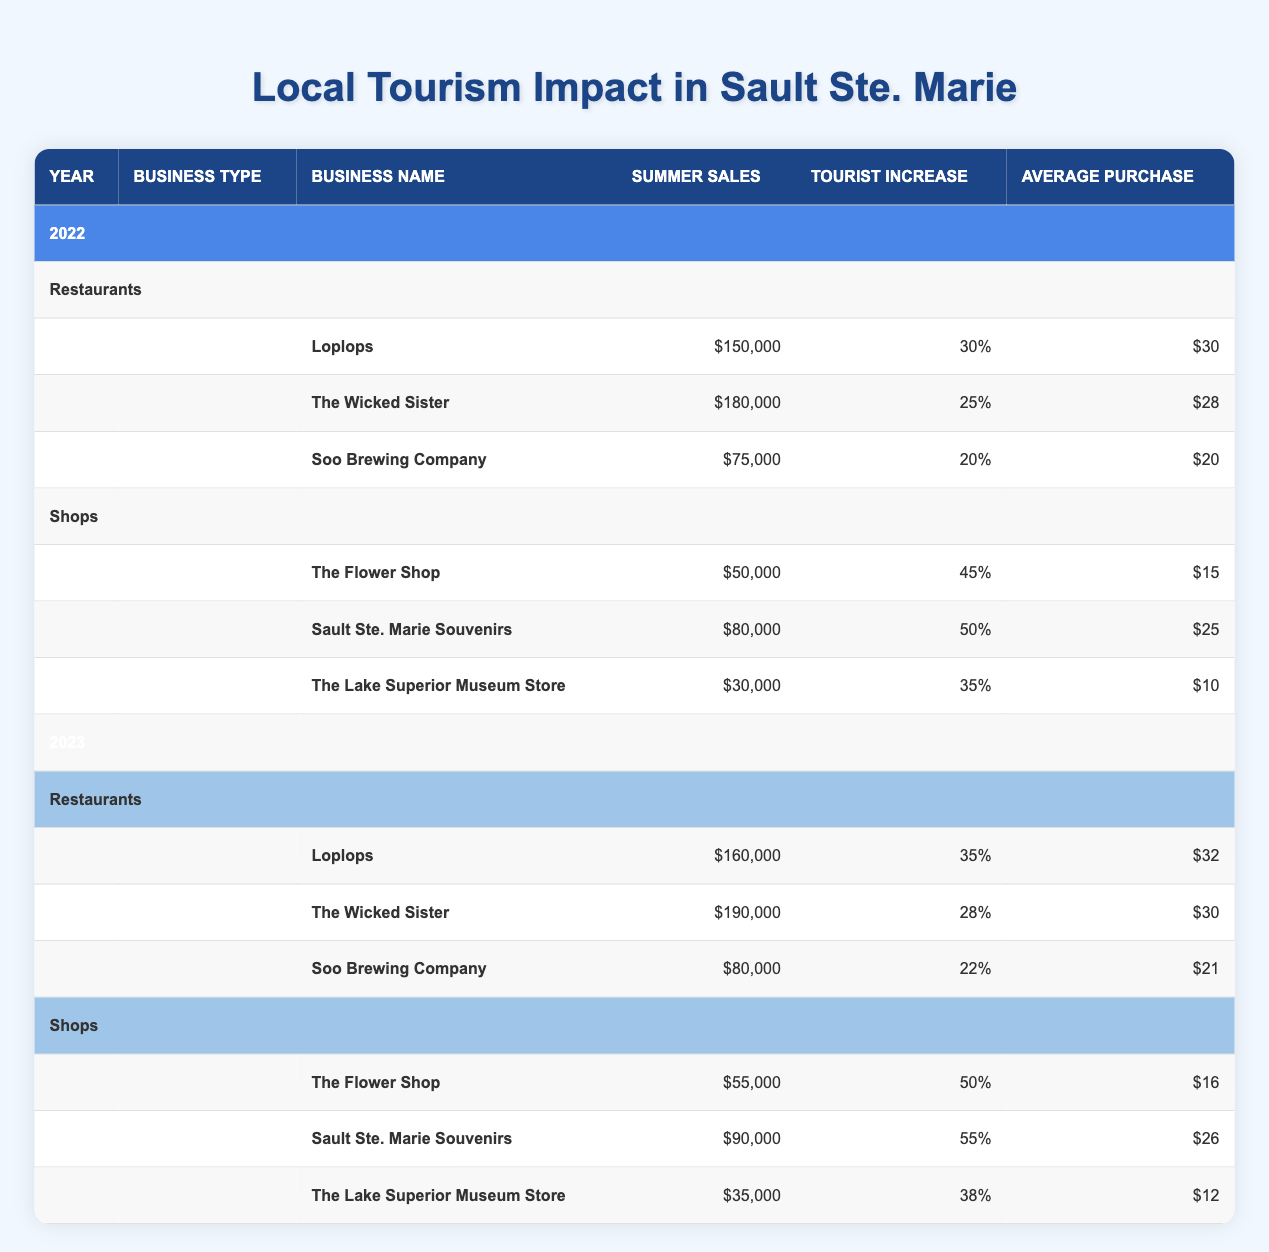What were Loplops' summer sales in 2023? According to the table, Loplops' summer sales in 2023 are listed as $160,000.
Answer: 160,000 How much did the summer sales of The Wicked Sister increase from 2022 to 2023? The summer sales for The Wicked Sister in 2022 were $180,000, and in 2023 they were $190,000. To find the increase, subtract 180,000 from 190,000, which equals 10,000.
Answer: 10,000 What is the average ticket size of Soo Brewing Company in 2022? The average ticket size for Soo Brewing Company in 2022 is indicated in the table as $20.
Answer: 20 Did Sault Ste. Marie Souvenirs have a higher tourist increase percentage than The Flower Shop in 2023? In 2023, Sault Ste. Marie Souvenirs had a tourist increase percentage of 55%, whereas The Flower Shop had a percentage of 50%. Since 55% is greater than 50%, the answer is yes.
Answer: Yes What is the total summer sales for restaurants in 2022? The summer sales for restaurants in 2022 include Loplops ($150,000), The Wicked Sister ($180,000), and Soo Brewing Company ($75,000). Adding these values gives: 150,000 + 180,000 + 75,000 = 405,000.
Answer: 405,000 Which shop had the highest average purchase size in 2022? The average purchase sizes in 2022 were: The Flower Shop ($15), Sault Ste. Marie Souvenirs ($25), and The Lake Superior Museum Store ($10). The highest value is $25 from Sault Ste. Marie Souvenirs.
Answer: Sault Ste. Marie Souvenirs What were the combined summer sales of The Flower Shop in 2022 and 2023? The summer sales for The Flower Shop were $50,000 in 2022 and $55,000 in 2023. Adding these amounts results in 50,000 + 55,000 = 105,000.
Answer: 105,000 Which year showed a greater increase in summer sales for Soo Brewing Company? For Soo Brewing Company, summer sales were $75,000 in 2022 and $80,000 in 2023. The increase from 2022 to 2023 is 80,000 - 75,000 = 5,000. The sales did not decrease, so no year had less sales. The increase was consistent.
Answer: 2023 What is the average summer sales for shops in 2023? The summer sales for shops in 2023 are: The Flower Shop ($55,000), Sault Ste. Marie Souvenirs ($90,000), and The Lake Superior Museum Store ($35,000). The total sales are 55,000 + 90,000 + 35,000 = 180,000. Dividing by 3 gives an average of 180,000 / 3 = 60,000.
Answer: 60,000 Did any restaurant's average ticket size decrease from 2022 to 2023? The average ticket sizes are: Loplops increased from $30 to $32, The Wicked Sister was stable at $30, and Soo Brewing Company increased from $20 to $21. Since all restaurants either increased or stayed the same, none had a decrease.
Answer: No 